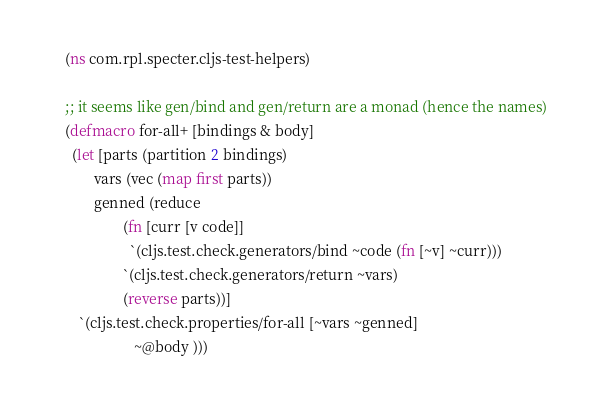<code> <loc_0><loc_0><loc_500><loc_500><_Clojure_>(ns com.rpl.specter.cljs-test-helpers)

;; it seems like gen/bind and gen/return are a monad (hence the names)
(defmacro for-all+ [bindings & body]
  (let [parts (partition 2 bindings)
        vars (vec (map first parts))
        genned (reduce
                (fn [curr [v code]]
                  `(cljs.test.check.generators/bind ~code (fn [~v] ~curr)))
                `(cljs.test.check.generators/return ~vars)
                (reverse parts))]
    `(cljs.test.check.properties/for-all [~vars ~genned]
                   ~@body )))
</code> 